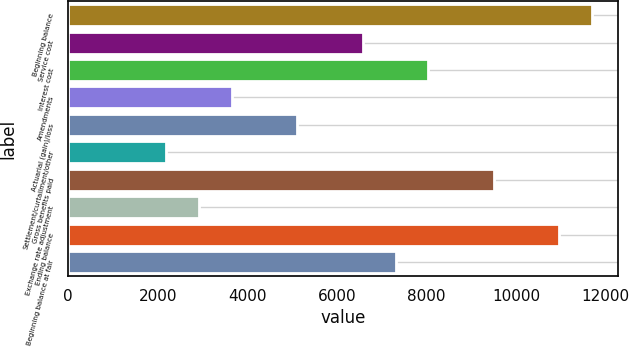Convert chart to OTSL. <chart><loc_0><loc_0><loc_500><loc_500><bar_chart><fcel>Beginning balance<fcel>Service cost<fcel>Interest cost<fcel>Amendments<fcel>Actuarial (gain)/loss<fcel>Settlement/curtailment/other<fcel>Gross benefits paid<fcel>Exchange rate adjustment<fcel>Ending balance<fcel>Beginning balance at fair<nl><fcel>11689<fcel>6575.5<fcel>8036.5<fcel>3653.5<fcel>5114.5<fcel>2192.5<fcel>9497.5<fcel>2923<fcel>10958.5<fcel>7306<nl></chart> 